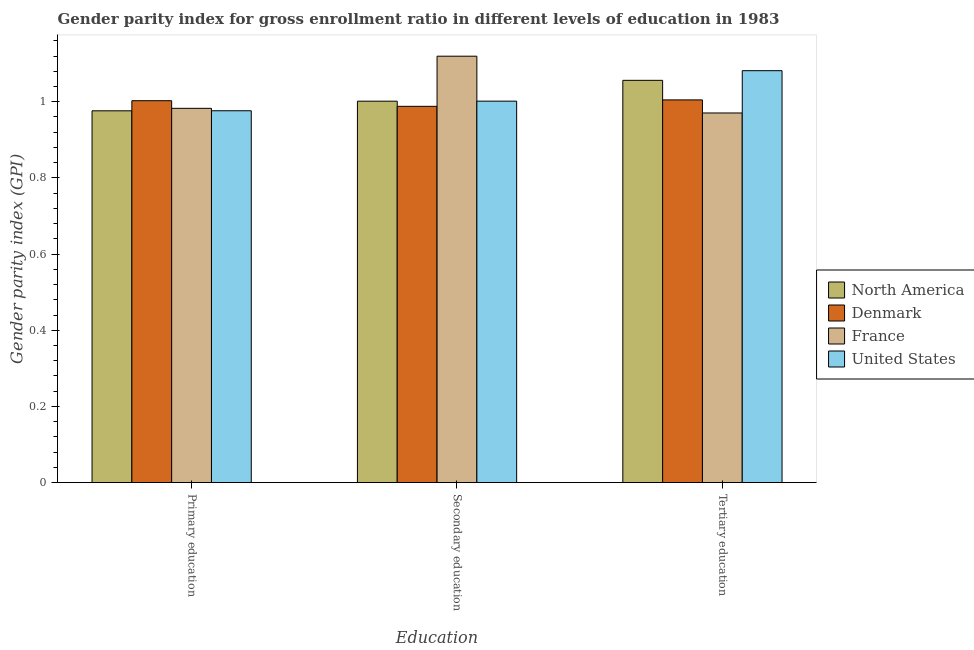How many different coloured bars are there?
Provide a short and direct response. 4. How many groups of bars are there?
Provide a succinct answer. 3. Are the number of bars per tick equal to the number of legend labels?
Your answer should be very brief. Yes. Are the number of bars on each tick of the X-axis equal?
Offer a terse response. Yes. How many bars are there on the 3rd tick from the left?
Give a very brief answer. 4. What is the gender parity index in primary education in Denmark?
Your answer should be very brief. 1. Across all countries, what is the maximum gender parity index in primary education?
Provide a succinct answer. 1. Across all countries, what is the minimum gender parity index in secondary education?
Offer a terse response. 0.99. In which country was the gender parity index in primary education minimum?
Provide a succinct answer. North America. What is the total gender parity index in secondary education in the graph?
Your response must be concise. 4.11. What is the difference between the gender parity index in primary education in North America and that in Denmark?
Your answer should be very brief. -0.03. What is the difference between the gender parity index in secondary education in France and the gender parity index in tertiary education in North America?
Your response must be concise. 0.06. What is the average gender parity index in secondary education per country?
Your response must be concise. 1.03. What is the difference between the gender parity index in secondary education and gender parity index in primary education in United States?
Provide a short and direct response. 0.03. In how many countries, is the gender parity index in tertiary education greater than 0.16 ?
Ensure brevity in your answer.  4. What is the ratio of the gender parity index in secondary education in Denmark to that in North America?
Give a very brief answer. 0.99. Is the difference between the gender parity index in tertiary education in France and Denmark greater than the difference between the gender parity index in primary education in France and Denmark?
Your answer should be compact. No. What is the difference between the highest and the second highest gender parity index in primary education?
Give a very brief answer. 0.02. What is the difference between the highest and the lowest gender parity index in secondary education?
Your response must be concise. 0.13. In how many countries, is the gender parity index in tertiary education greater than the average gender parity index in tertiary education taken over all countries?
Offer a very short reply. 2. What does the 3rd bar from the right in Primary education represents?
Your answer should be compact. Denmark. Is it the case that in every country, the sum of the gender parity index in primary education and gender parity index in secondary education is greater than the gender parity index in tertiary education?
Provide a succinct answer. Yes. How many bars are there?
Keep it short and to the point. 12. How many countries are there in the graph?
Make the answer very short. 4. Are the values on the major ticks of Y-axis written in scientific E-notation?
Offer a terse response. No. Does the graph contain any zero values?
Offer a very short reply. No. How many legend labels are there?
Keep it short and to the point. 4. How are the legend labels stacked?
Provide a short and direct response. Vertical. What is the title of the graph?
Your answer should be compact. Gender parity index for gross enrollment ratio in different levels of education in 1983. What is the label or title of the X-axis?
Offer a very short reply. Education. What is the label or title of the Y-axis?
Provide a succinct answer. Gender parity index (GPI). What is the Gender parity index (GPI) of North America in Primary education?
Your answer should be compact. 0.98. What is the Gender parity index (GPI) in Denmark in Primary education?
Your response must be concise. 1. What is the Gender parity index (GPI) in France in Primary education?
Provide a short and direct response. 0.98. What is the Gender parity index (GPI) of United States in Primary education?
Keep it short and to the point. 0.98. What is the Gender parity index (GPI) of North America in Secondary education?
Your answer should be compact. 1. What is the Gender parity index (GPI) of Denmark in Secondary education?
Give a very brief answer. 0.99. What is the Gender parity index (GPI) in France in Secondary education?
Give a very brief answer. 1.12. What is the Gender parity index (GPI) of United States in Secondary education?
Ensure brevity in your answer.  1. What is the Gender parity index (GPI) in North America in Tertiary education?
Your answer should be compact. 1.06. What is the Gender parity index (GPI) in Denmark in Tertiary education?
Make the answer very short. 1. What is the Gender parity index (GPI) of France in Tertiary education?
Your answer should be very brief. 0.97. What is the Gender parity index (GPI) in United States in Tertiary education?
Keep it short and to the point. 1.08. Across all Education, what is the maximum Gender parity index (GPI) in North America?
Keep it short and to the point. 1.06. Across all Education, what is the maximum Gender parity index (GPI) of Denmark?
Ensure brevity in your answer.  1. Across all Education, what is the maximum Gender parity index (GPI) of France?
Your response must be concise. 1.12. Across all Education, what is the maximum Gender parity index (GPI) of United States?
Make the answer very short. 1.08. Across all Education, what is the minimum Gender parity index (GPI) in North America?
Your answer should be compact. 0.98. Across all Education, what is the minimum Gender parity index (GPI) of Denmark?
Ensure brevity in your answer.  0.99. Across all Education, what is the minimum Gender parity index (GPI) of France?
Ensure brevity in your answer.  0.97. Across all Education, what is the minimum Gender parity index (GPI) in United States?
Offer a very short reply. 0.98. What is the total Gender parity index (GPI) of North America in the graph?
Offer a terse response. 3.03. What is the total Gender parity index (GPI) in Denmark in the graph?
Your answer should be compact. 3. What is the total Gender parity index (GPI) in France in the graph?
Offer a terse response. 3.07. What is the total Gender parity index (GPI) in United States in the graph?
Offer a terse response. 3.06. What is the difference between the Gender parity index (GPI) in North America in Primary education and that in Secondary education?
Provide a succinct answer. -0.03. What is the difference between the Gender parity index (GPI) of Denmark in Primary education and that in Secondary education?
Keep it short and to the point. 0.01. What is the difference between the Gender parity index (GPI) of France in Primary education and that in Secondary education?
Provide a succinct answer. -0.14. What is the difference between the Gender parity index (GPI) in United States in Primary education and that in Secondary education?
Offer a terse response. -0.03. What is the difference between the Gender parity index (GPI) in North America in Primary education and that in Tertiary education?
Provide a short and direct response. -0.08. What is the difference between the Gender parity index (GPI) in Denmark in Primary education and that in Tertiary education?
Your answer should be very brief. -0. What is the difference between the Gender parity index (GPI) in France in Primary education and that in Tertiary education?
Keep it short and to the point. 0.01. What is the difference between the Gender parity index (GPI) in United States in Primary education and that in Tertiary education?
Ensure brevity in your answer.  -0.11. What is the difference between the Gender parity index (GPI) of North America in Secondary education and that in Tertiary education?
Your response must be concise. -0.05. What is the difference between the Gender parity index (GPI) in Denmark in Secondary education and that in Tertiary education?
Offer a terse response. -0.02. What is the difference between the Gender parity index (GPI) in France in Secondary education and that in Tertiary education?
Offer a terse response. 0.15. What is the difference between the Gender parity index (GPI) of United States in Secondary education and that in Tertiary education?
Provide a short and direct response. -0.08. What is the difference between the Gender parity index (GPI) in North America in Primary education and the Gender parity index (GPI) in Denmark in Secondary education?
Ensure brevity in your answer.  -0.01. What is the difference between the Gender parity index (GPI) of North America in Primary education and the Gender parity index (GPI) of France in Secondary education?
Offer a very short reply. -0.14. What is the difference between the Gender parity index (GPI) in North America in Primary education and the Gender parity index (GPI) in United States in Secondary education?
Offer a terse response. -0.03. What is the difference between the Gender parity index (GPI) in Denmark in Primary education and the Gender parity index (GPI) in France in Secondary education?
Offer a very short reply. -0.12. What is the difference between the Gender parity index (GPI) in Denmark in Primary education and the Gender parity index (GPI) in United States in Secondary education?
Give a very brief answer. 0. What is the difference between the Gender parity index (GPI) in France in Primary education and the Gender parity index (GPI) in United States in Secondary education?
Provide a short and direct response. -0.02. What is the difference between the Gender parity index (GPI) in North America in Primary education and the Gender parity index (GPI) in Denmark in Tertiary education?
Your answer should be compact. -0.03. What is the difference between the Gender parity index (GPI) of North America in Primary education and the Gender parity index (GPI) of France in Tertiary education?
Make the answer very short. 0.01. What is the difference between the Gender parity index (GPI) of North America in Primary education and the Gender parity index (GPI) of United States in Tertiary education?
Offer a terse response. -0.11. What is the difference between the Gender parity index (GPI) of Denmark in Primary education and the Gender parity index (GPI) of France in Tertiary education?
Your answer should be compact. 0.03. What is the difference between the Gender parity index (GPI) in Denmark in Primary education and the Gender parity index (GPI) in United States in Tertiary education?
Keep it short and to the point. -0.08. What is the difference between the Gender parity index (GPI) in France in Primary education and the Gender parity index (GPI) in United States in Tertiary education?
Provide a short and direct response. -0.1. What is the difference between the Gender parity index (GPI) of North America in Secondary education and the Gender parity index (GPI) of Denmark in Tertiary education?
Your response must be concise. -0. What is the difference between the Gender parity index (GPI) of North America in Secondary education and the Gender parity index (GPI) of France in Tertiary education?
Offer a very short reply. 0.03. What is the difference between the Gender parity index (GPI) in North America in Secondary education and the Gender parity index (GPI) in United States in Tertiary education?
Your answer should be compact. -0.08. What is the difference between the Gender parity index (GPI) of Denmark in Secondary education and the Gender parity index (GPI) of France in Tertiary education?
Your answer should be compact. 0.02. What is the difference between the Gender parity index (GPI) of Denmark in Secondary education and the Gender parity index (GPI) of United States in Tertiary education?
Offer a very short reply. -0.09. What is the difference between the Gender parity index (GPI) of France in Secondary education and the Gender parity index (GPI) of United States in Tertiary education?
Offer a terse response. 0.04. What is the average Gender parity index (GPI) in North America per Education?
Your answer should be very brief. 1.01. What is the average Gender parity index (GPI) of Denmark per Education?
Make the answer very short. 1. What is the average Gender parity index (GPI) of France per Education?
Your answer should be compact. 1.02. What is the average Gender parity index (GPI) of United States per Education?
Keep it short and to the point. 1.02. What is the difference between the Gender parity index (GPI) of North America and Gender parity index (GPI) of Denmark in Primary education?
Provide a succinct answer. -0.03. What is the difference between the Gender parity index (GPI) in North America and Gender parity index (GPI) in France in Primary education?
Keep it short and to the point. -0.01. What is the difference between the Gender parity index (GPI) of North America and Gender parity index (GPI) of United States in Primary education?
Provide a short and direct response. -0. What is the difference between the Gender parity index (GPI) in Denmark and Gender parity index (GPI) in France in Primary education?
Your response must be concise. 0.02. What is the difference between the Gender parity index (GPI) in Denmark and Gender parity index (GPI) in United States in Primary education?
Your response must be concise. 0.03. What is the difference between the Gender parity index (GPI) in France and Gender parity index (GPI) in United States in Primary education?
Your answer should be compact. 0.01. What is the difference between the Gender parity index (GPI) in North America and Gender parity index (GPI) in Denmark in Secondary education?
Give a very brief answer. 0.01. What is the difference between the Gender parity index (GPI) of North America and Gender parity index (GPI) of France in Secondary education?
Offer a terse response. -0.12. What is the difference between the Gender parity index (GPI) in North America and Gender parity index (GPI) in United States in Secondary education?
Your answer should be very brief. -0. What is the difference between the Gender parity index (GPI) of Denmark and Gender parity index (GPI) of France in Secondary education?
Give a very brief answer. -0.13. What is the difference between the Gender parity index (GPI) in Denmark and Gender parity index (GPI) in United States in Secondary education?
Offer a terse response. -0.01. What is the difference between the Gender parity index (GPI) of France and Gender parity index (GPI) of United States in Secondary education?
Provide a short and direct response. 0.12. What is the difference between the Gender parity index (GPI) in North America and Gender parity index (GPI) in Denmark in Tertiary education?
Keep it short and to the point. 0.05. What is the difference between the Gender parity index (GPI) in North America and Gender parity index (GPI) in France in Tertiary education?
Offer a terse response. 0.09. What is the difference between the Gender parity index (GPI) in North America and Gender parity index (GPI) in United States in Tertiary education?
Offer a very short reply. -0.03. What is the difference between the Gender parity index (GPI) in Denmark and Gender parity index (GPI) in France in Tertiary education?
Give a very brief answer. 0.03. What is the difference between the Gender parity index (GPI) of Denmark and Gender parity index (GPI) of United States in Tertiary education?
Your answer should be compact. -0.08. What is the difference between the Gender parity index (GPI) of France and Gender parity index (GPI) of United States in Tertiary education?
Provide a short and direct response. -0.11. What is the ratio of the Gender parity index (GPI) of North America in Primary education to that in Secondary education?
Give a very brief answer. 0.97. What is the ratio of the Gender parity index (GPI) of France in Primary education to that in Secondary education?
Offer a very short reply. 0.88. What is the ratio of the Gender parity index (GPI) of United States in Primary education to that in Secondary education?
Provide a short and direct response. 0.97. What is the ratio of the Gender parity index (GPI) in North America in Primary education to that in Tertiary education?
Your answer should be compact. 0.92. What is the ratio of the Gender parity index (GPI) in Denmark in Primary education to that in Tertiary education?
Offer a very short reply. 1. What is the ratio of the Gender parity index (GPI) of France in Primary education to that in Tertiary education?
Ensure brevity in your answer.  1.01. What is the ratio of the Gender parity index (GPI) in United States in Primary education to that in Tertiary education?
Your answer should be very brief. 0.9. What is the ratio of the Gender parity index (GPI) in North America in Secondary education to that in Tertiary education?
Provide a succinct answer. 0.95. What is the ratio of the Gender parity index (GPI) in Denmark in Secondary education to that in Tertiary education?
Provide a succinct answer. 0.98. What is the ratio of the Gender parity index (GPI) of France in Secondary education to that in Tertiary education?
Keep it short and to the point. 1.15. What is the ratio of the Gender parity index (GPI) of United States in Secondary education to that in Tertiary education?
Provide a succinct answer. 0.93. What is the difference between the highest and the second highest Gender parity index (GPI) in North America?
Offer a terse response. 0.05. What is the difference between the highest and the second highest Gender parity index (GPI) of Denmark?
Your response must be concise. 0. What is the difference between the highest and the second highest Gender parity index (GPI) of France?
Your answer should be very brief. 0.14. What is the difference between the highest and the second highest Gender parity index (GPI) in United States?
Provide a short and direct response. 0.08. What is the difference between the highest and the lowest Gender parity index (GPI) of North America?
Offer a terse response. 0.08. What is the difference between the highest and the lowest Gender parity index (GPI) of Denmark?
Offer a terse response. 0.02. What is the difference between the highest and the lowest Gender parity index (GPI) in France?
Ensure brevity in your answer.  0.15. What is the difference between the highest and the lowest Gender parity index (GPI) in United States?
Offer a terse response. 0.11. 